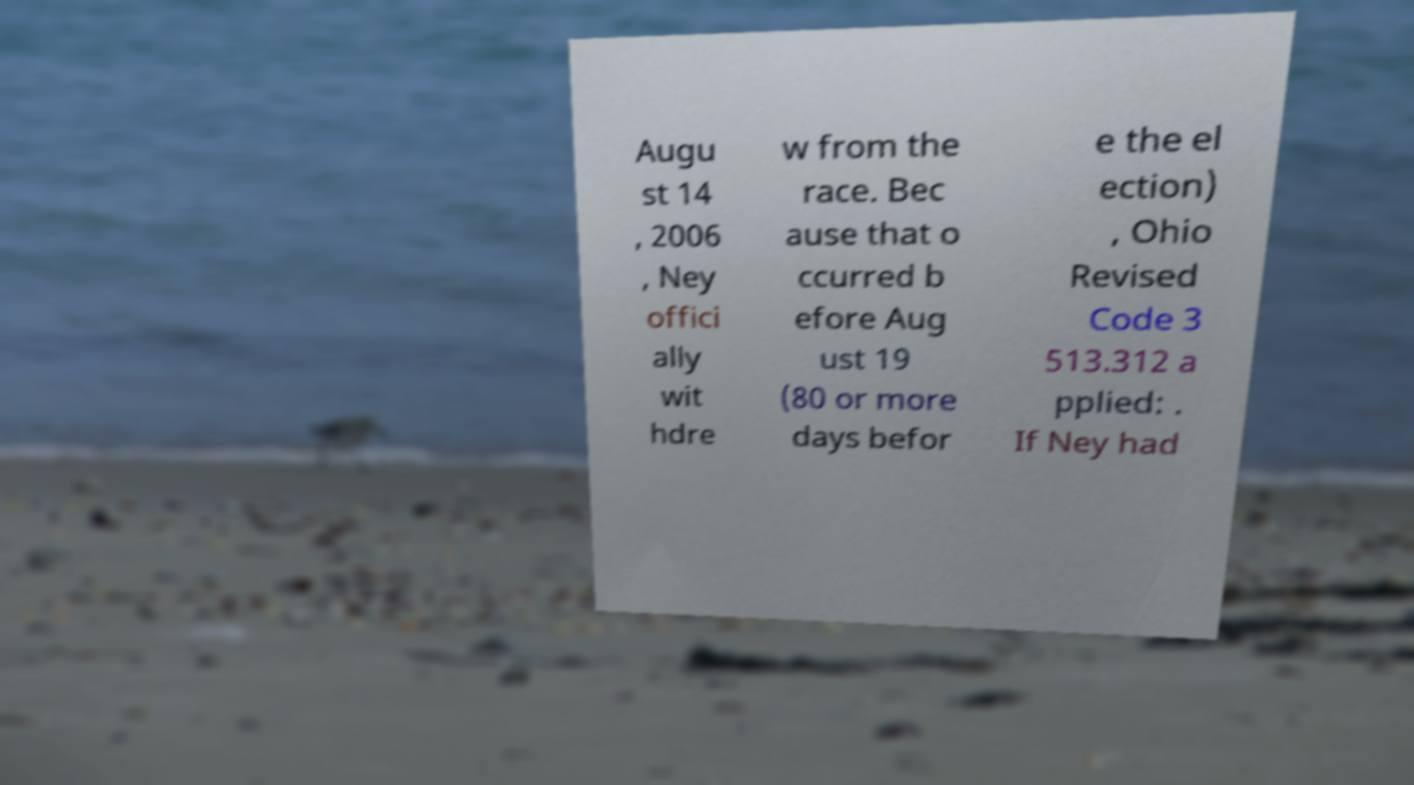Please read and relay the text visible in this image. What does it say? Augu st 14 , 2006 , Ney offici ally wit hdre w from the race. Bec ause that o ccurred b efore Aug ust 19 (80 or more days befor e the el ection) , Ohio Revised Code 3 513.312 a pplied: . If Ney had 